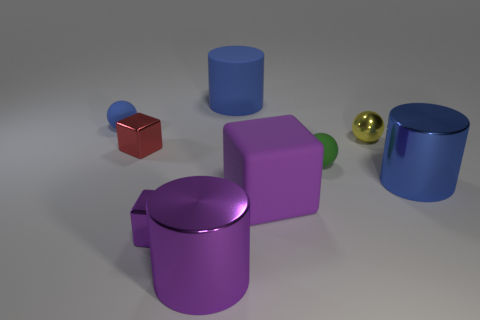Subtract 1 balls. How many balls are left? 2 Subtract all tiny matte spheres. How many spheres are left? 1 Subtract all cubes. How many objects are left? 6 Add 3 shiny objects. How many shiny objects exist? 8 Subtract 1 blue cylinders. How many objects are left? 8 Subtract all big purple objects. Subtract all blue cylinders. How many objects are left? 5 Add 6 small shiny blocks. How many small shiny blocks are left? 8 